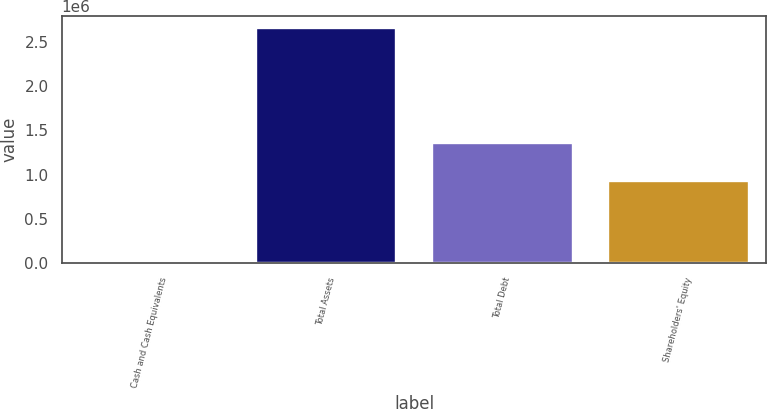Convert chart to OTSL. <chart><loc_0><loc_0><loc_500><loc_500><bar_chart><fcel>Cash and Cash Equivalents<fcel>Total Assets<fcel>Total Debt<fcel>Shareholders' Equity<nl><fcel>6200<fcel>2.6591e+06<fcel>1.35513e+06<fcel>924458<nl></chart> 